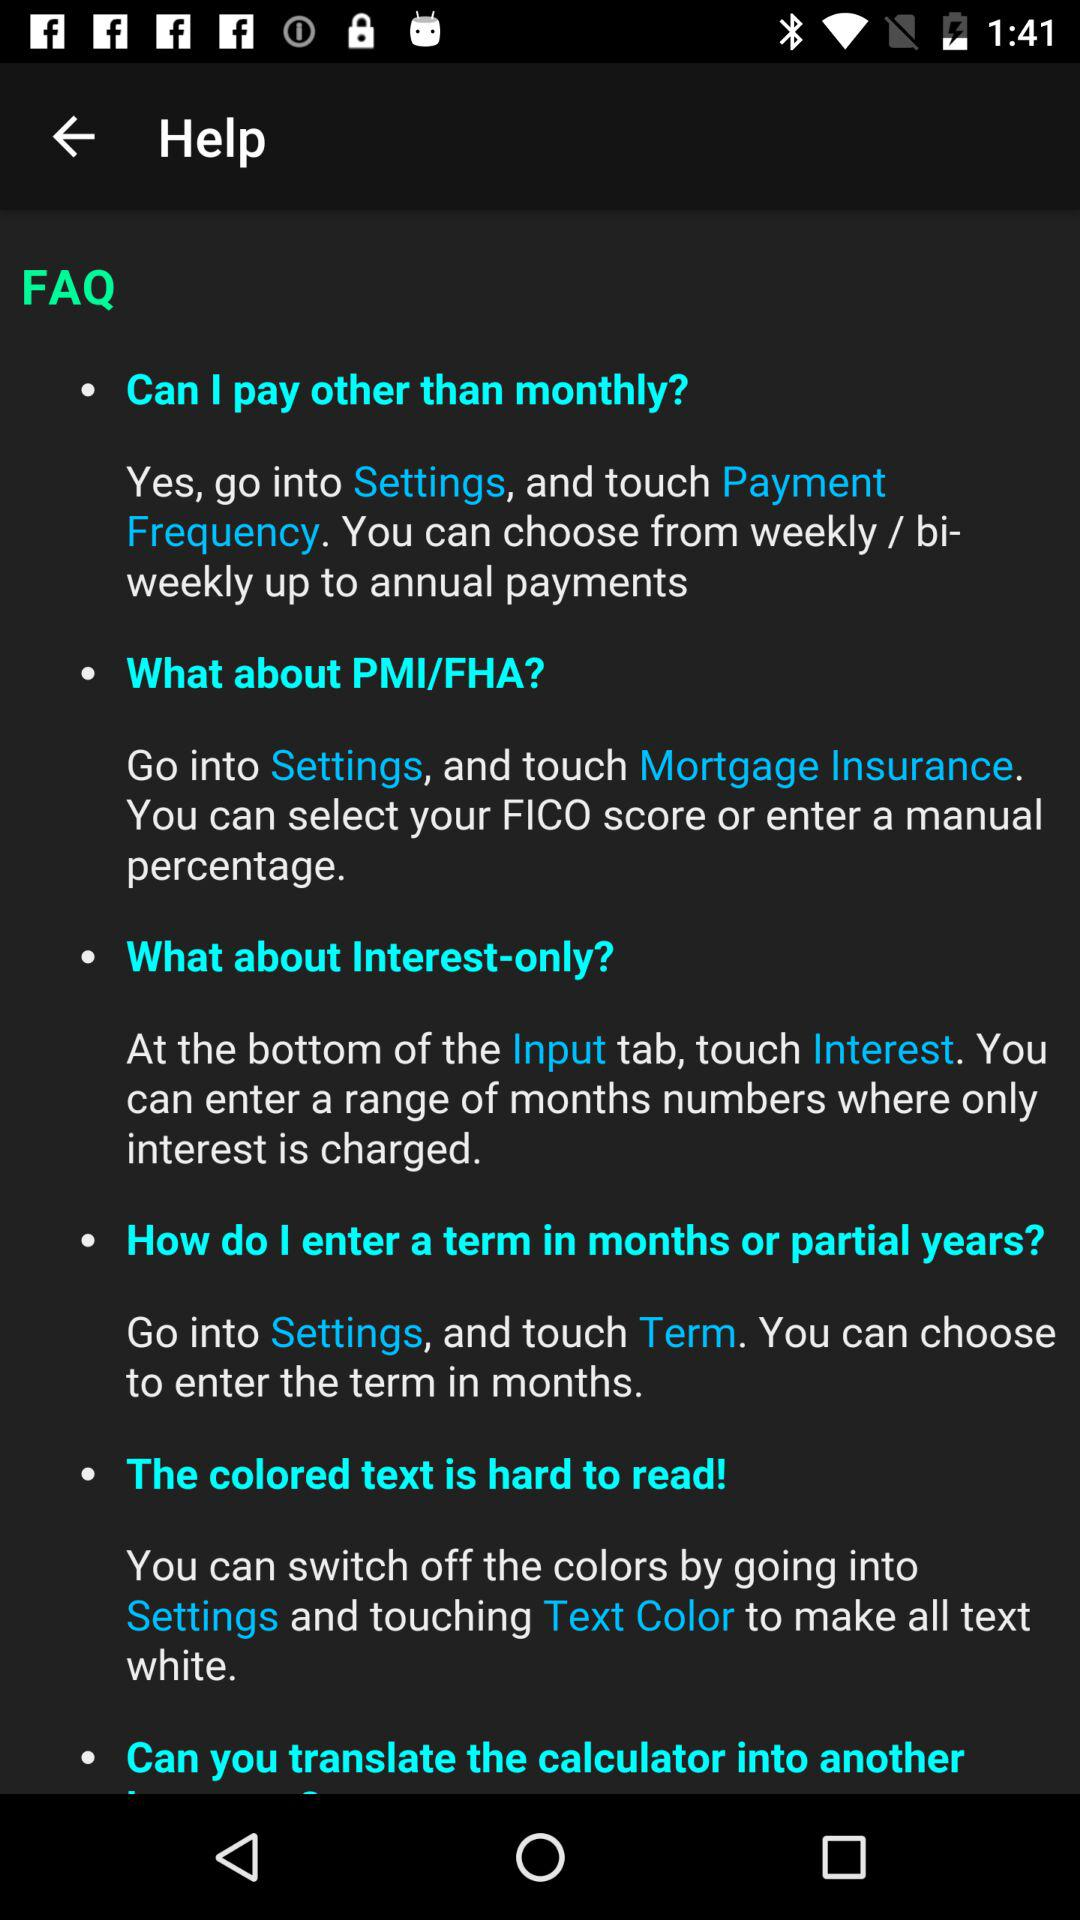How many FAQs mention payment frequency?
Answer the question using a single word or phrase. 1 